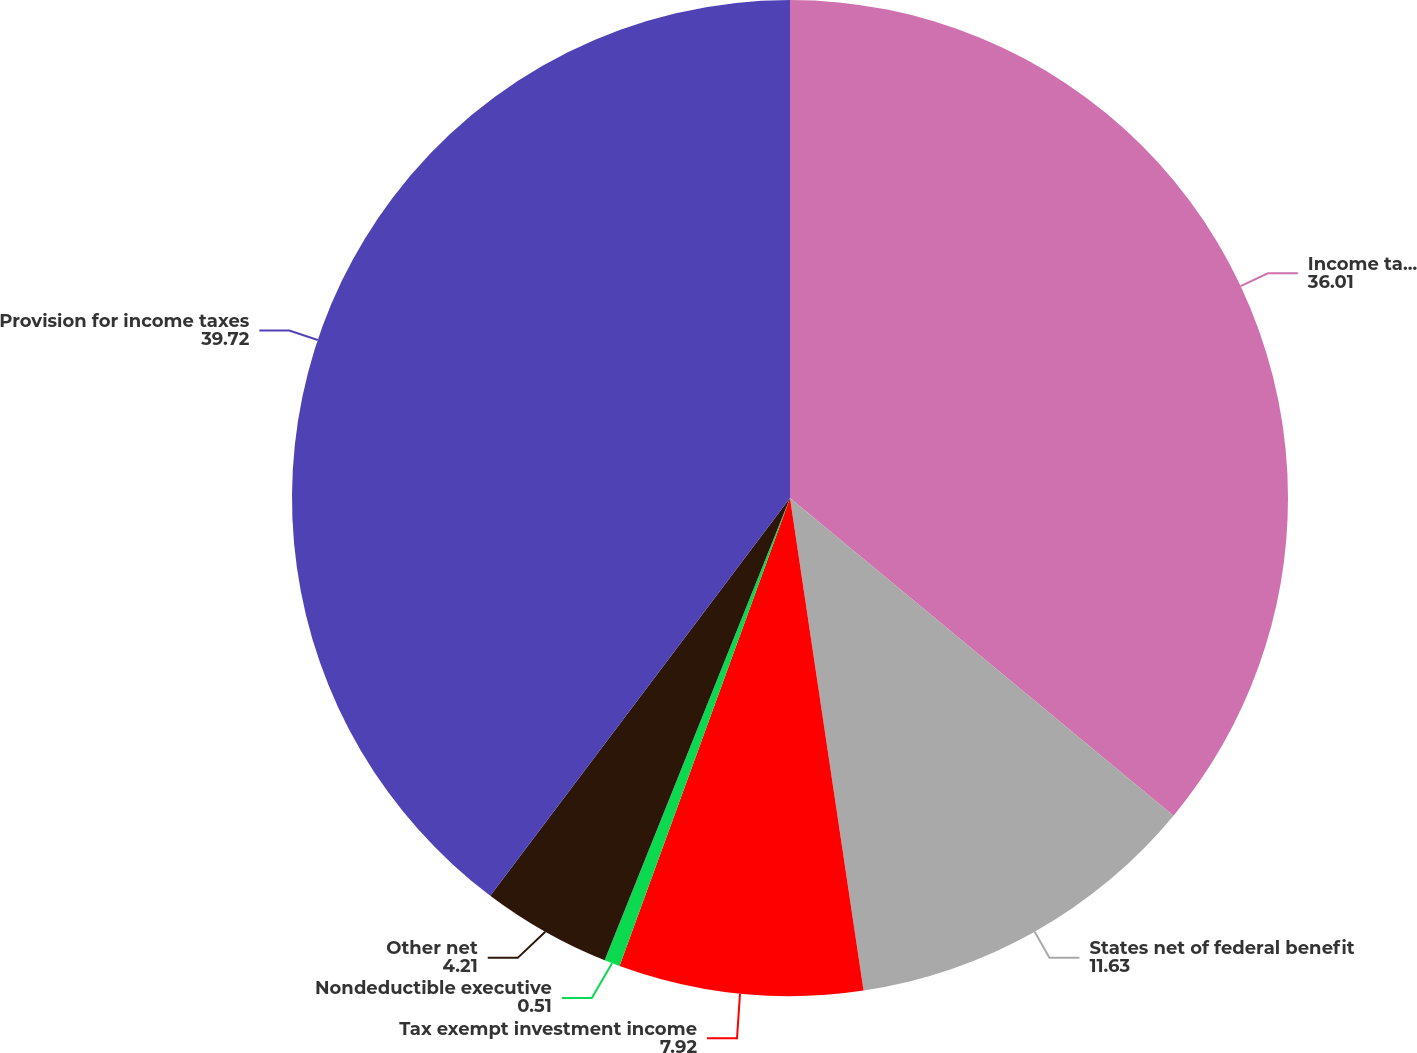Convert chart to OTSL. <chart><loc_0><loc_0><loc_500><loc_500><pie_chart><fcel>Income tax provision at<fcel>States net of federal benefit<fcel>Tax exempt investment income<fcel>Nondeductible executive<fcel>Other net<fcel>Provision for income taxes<nl><fcel>36.01%<fcel>11.63%<fcel>7.92%<fcel>0.51%<fcel>4.21%<fcel>39.72%<nl></chart> 